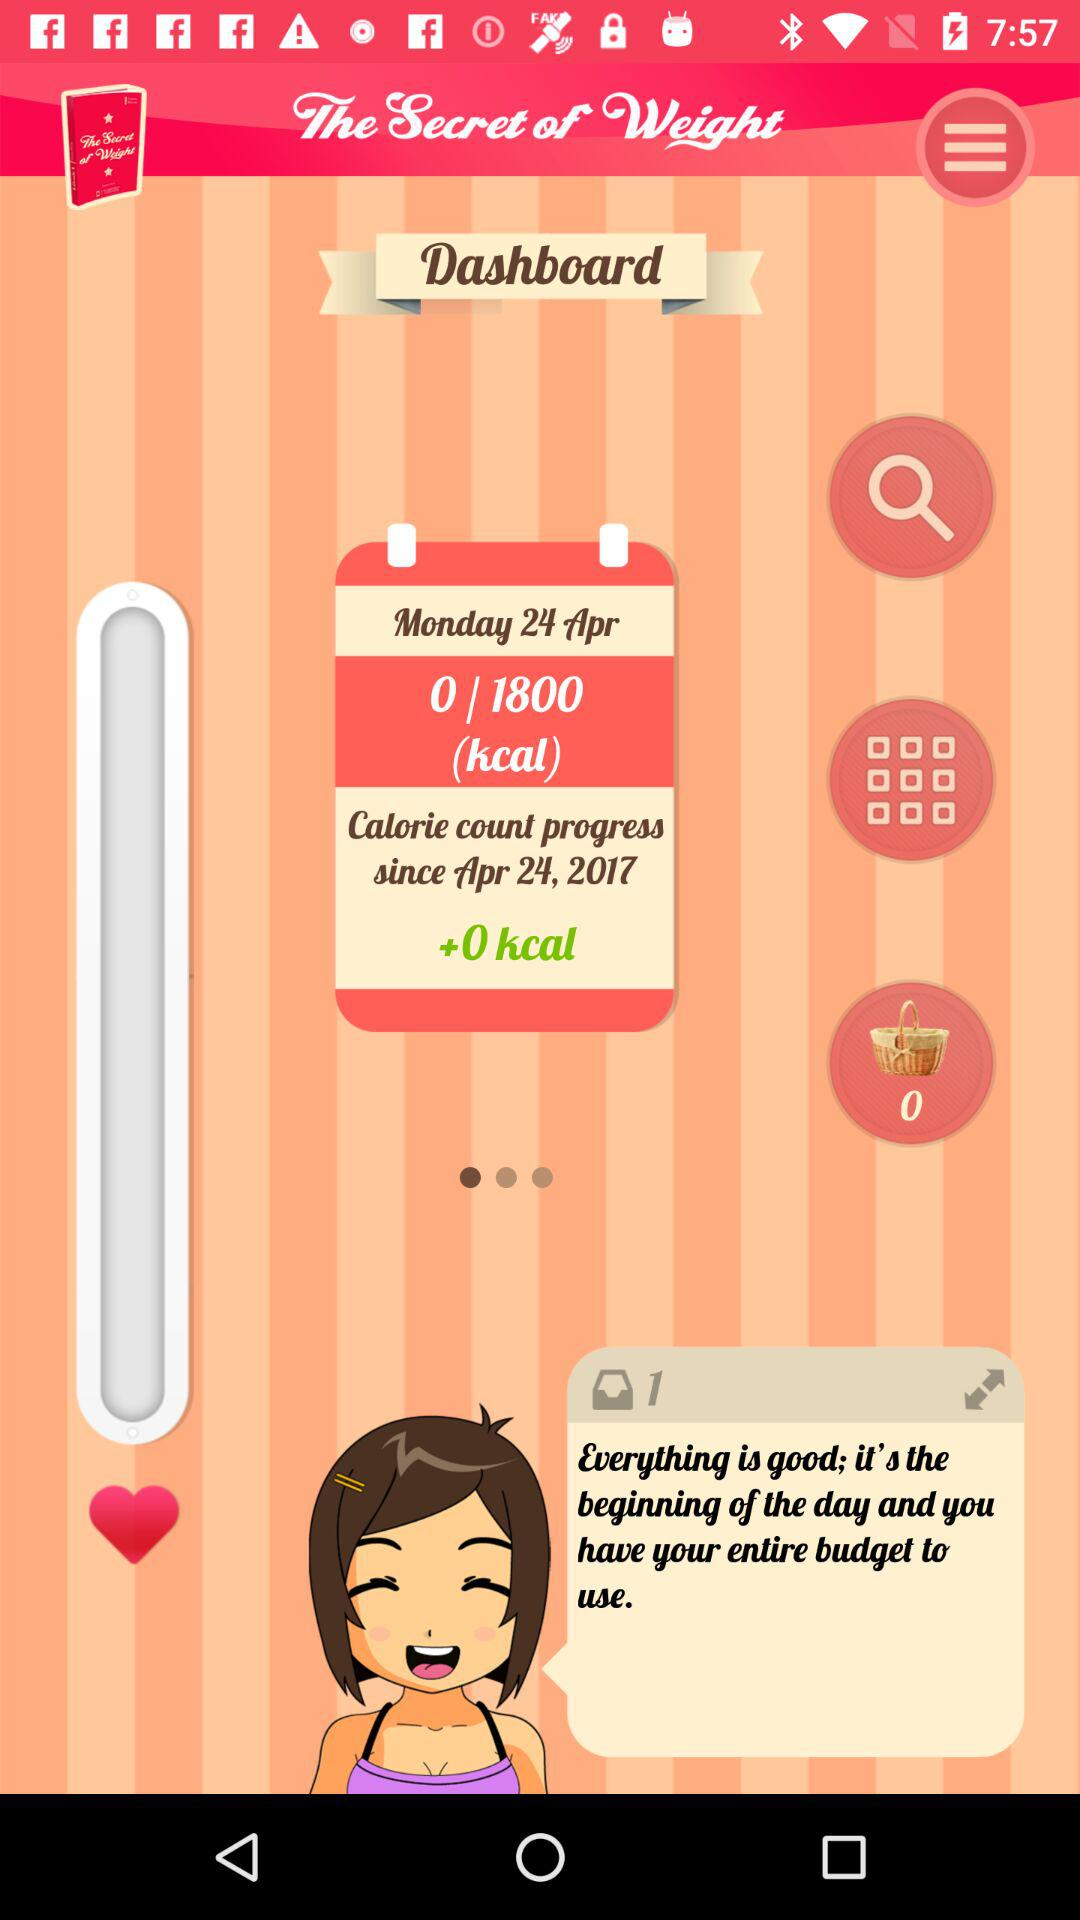What's the date? The date is Monday, April 24, 2017. 